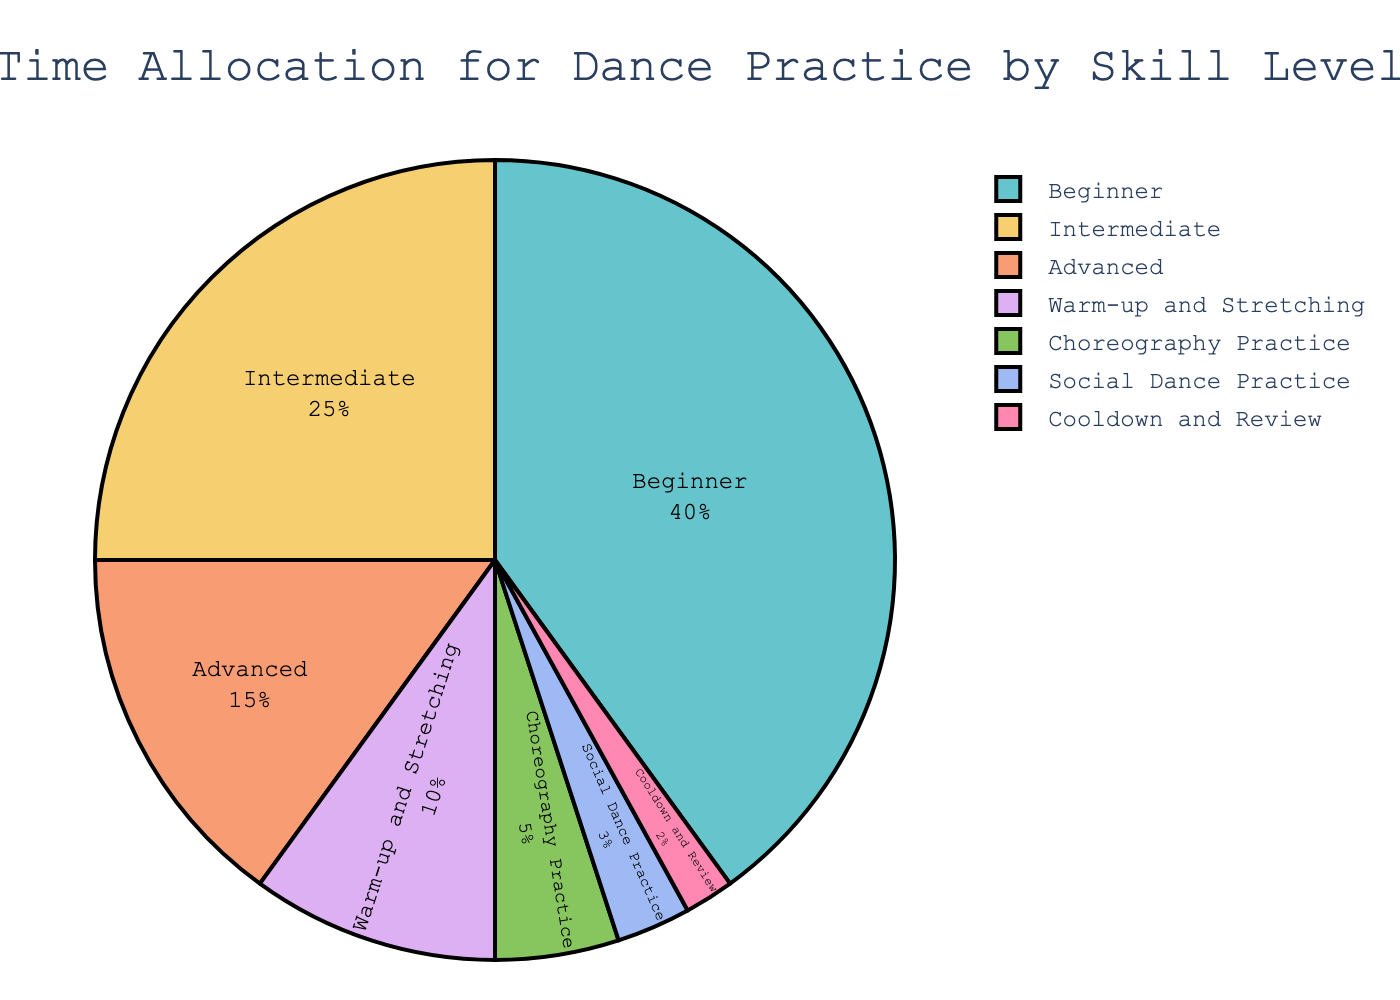How much more time is allocated to Beginner practice compared to Advanced practice? By examining the pie chart, we see that Beginner practice is allocated 40% while Advanced practice is allocated 15%. The difference can be calculated as 40% - 15% = 25%.
Answer: 25% What is the combined percentage of time allocated to Intermediate and Advanced practice? Add the percentages for Intermediate (25%) and Advanced (15%) practices. 25% + 15% = 40%.
Answer: 40% Which category has the smallest time allocation and what is its percentage? From the pie chart, Cooldown and Review has the smallest allocation with 2%.
Answer: Cooldown and Review, 2% Is more time allocated to Warm-up and Stretching or Choreography Practice? Comparing the segments, Warm-up and Stretching has 10% while Choreography Practice has 5%. So, more time is allocated to Warm-up and Stretching.
Answer: Warm-up and Stretching What is the total percentage of time allocated to activities other than skill-specific practices (Beginner, Intermediate, Advanced)? The activities other than skill-specific practices include Warm-up and Stretching (10%), Choreography Practice (5%), Social Dance Practice (3%), Cooldown and Review (2%). Adding these gives 10% + 5% + 3% + 2% = 20%.
Answer: 20% How does the percentage allocated to Beginner practice compare to the total percentage allocated to both Choreography and Social Dance Practice? The Beginner practice is allocated 40%. The total for Choreography (5%) and Social Dance Practice (3%) is 5% + 3% = 8%. Comparing these, Beginner practice is still significantly higher.
Answer: 40% compared to 8% Are there any two categories with equal time allocation? By looking at the pie chart, none of the categories have the same percentage allocation.
Answer: No If Warm-up and Stretching time was increased by 5%, how would that compare to the total time allocated to Intermediate and Advanced practices combined? Warm-up and Stretching currently has 10%. Increasing it by 5% makes it 15%. The combined time for Intermediate and Advanced practices is 25% + 15% = 40%. So, 15% is still less than 40%.
Answer: Less than What percentage of time is allocated to activities that specifically involve practicing dancing (i.e., excluding Warm-up and Stretching, and Cooldown and Review)? Adding the percentages for Beginner (40%), Intermediate (25%), Advanced (15%), Choreography Practice (5%), and Social Dance Practice (3%) gives 40% + 25% + 15% + 5% + 3% = 88%.
Answer: 88% What's the ratio of time allocated to Beginner practice to the time allocated to Cooldown and Review? The time allocation for Beginner practice is 40% and for Cooldown and Review is 2%. The ratio is 40% / 2% = 20:1.
Answer: 20:1 